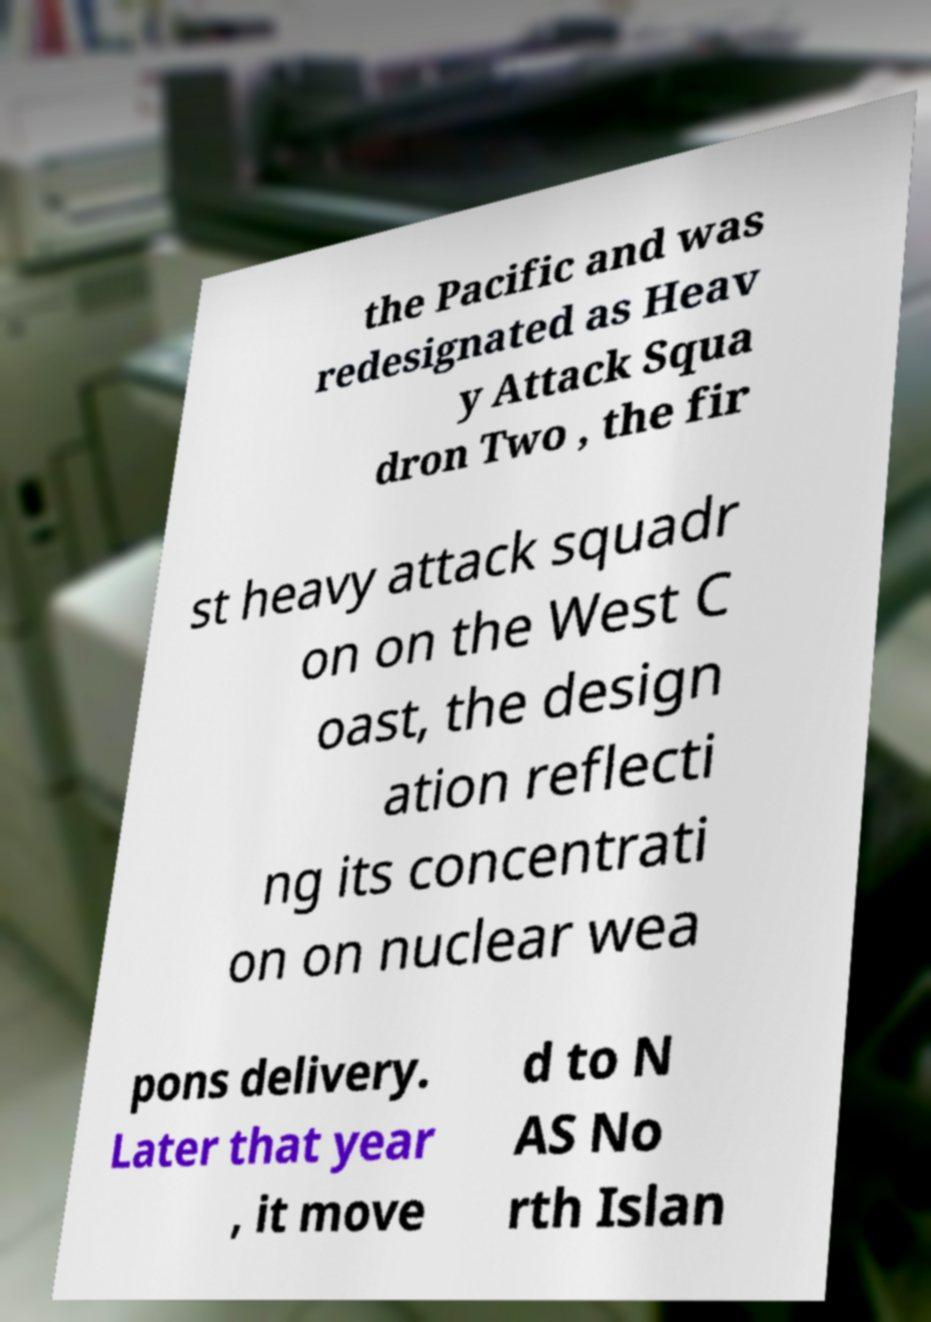Could you assist in decoding the text presented in this image and type it out clearly? the Pacific and was redesignated as Heav y Attack Squa dron Two , the fir st heavy attack squadr on on the West C oast, the design ation reflecti ng its concentrati on on nuclear wea pons delivery. Later that year , it move d to N AS No rth Islan 